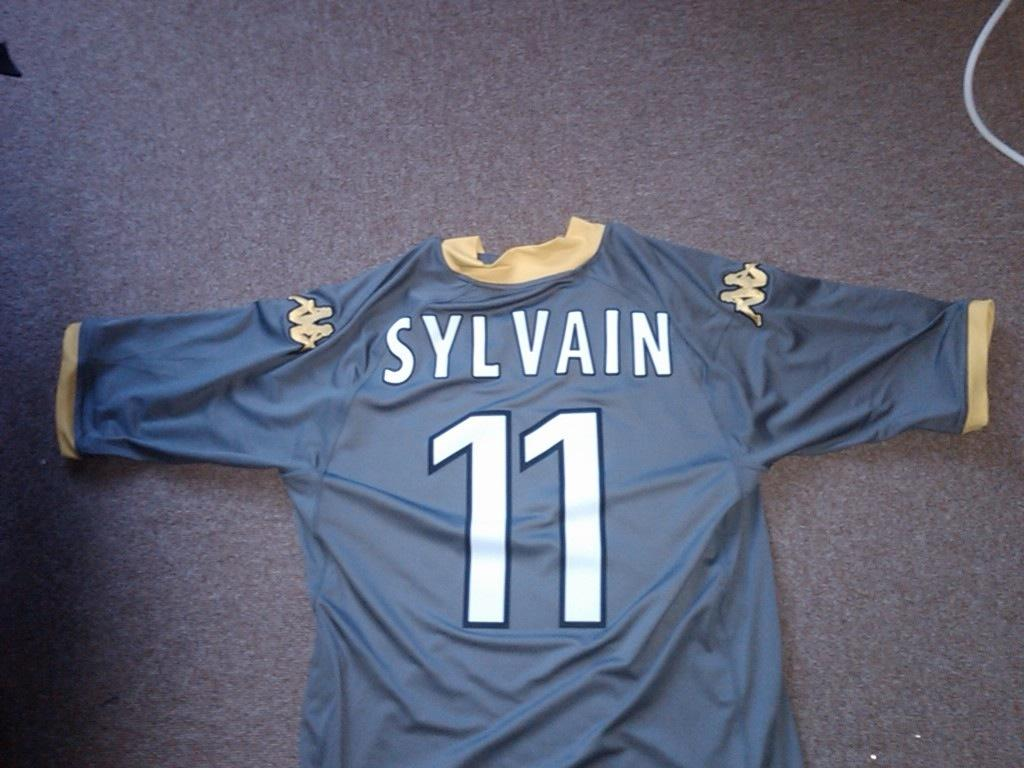<image>
Write a terse but informative summary of the picture. A blue and gold jersey for Sylvain #11 is displayed against a gray background. 